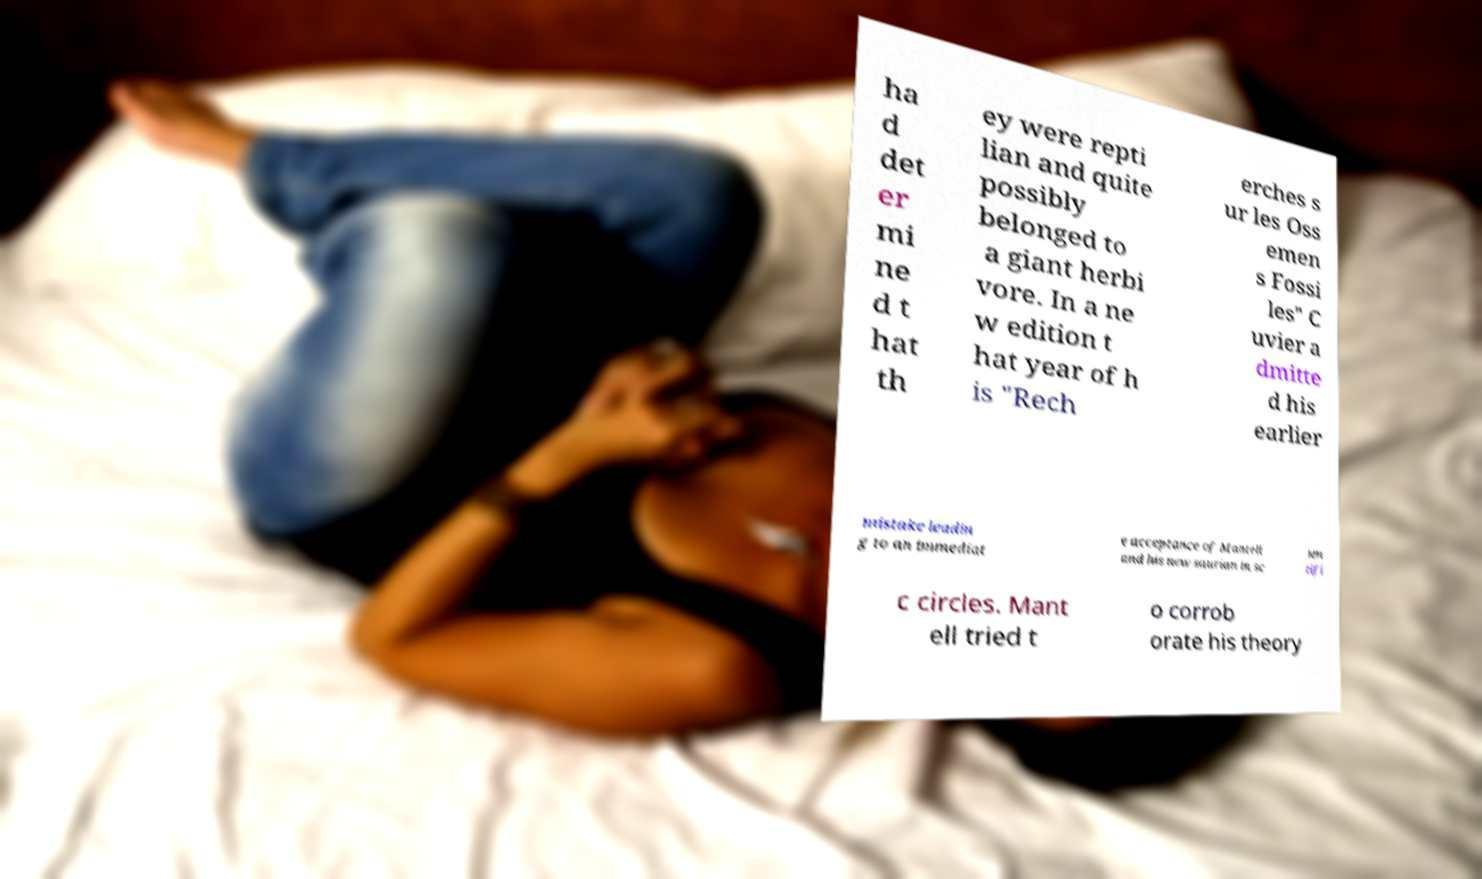Please read and relay the text visible in this image. What does it say? ha d det er mi ne d t hat th ey were repti lian and quite possibly belonged to a giant herbi vore. In a ne w edition t hat year of h is "Rech erches s ur les Oss emen s Fossi les" C uvier a dmitte d his earlier mistake leadin g to an immediat e acceptance of Mantell and his new saurian in sc ien tifi c circles. Mant ell tried t o corrob orate his theory 